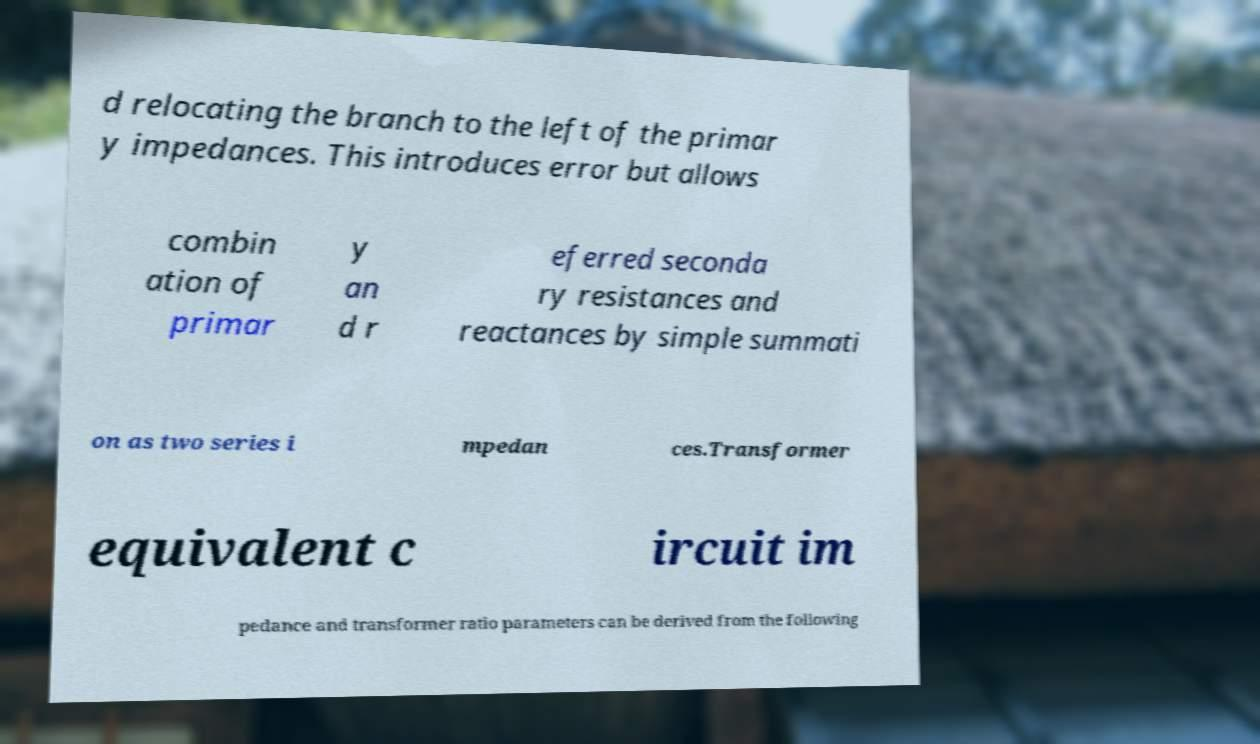Could you extract and type out the text from this image? d relocating the branch to the left of the primar y impedances. This introduces error but allows combin ation of primar y an d r eferred seconda ry resistances and reactances by simple summati on as two series i mpedan ces.Transformer equivalent c ircuit im pedance and transformer ratio parameters can be derived from the following 